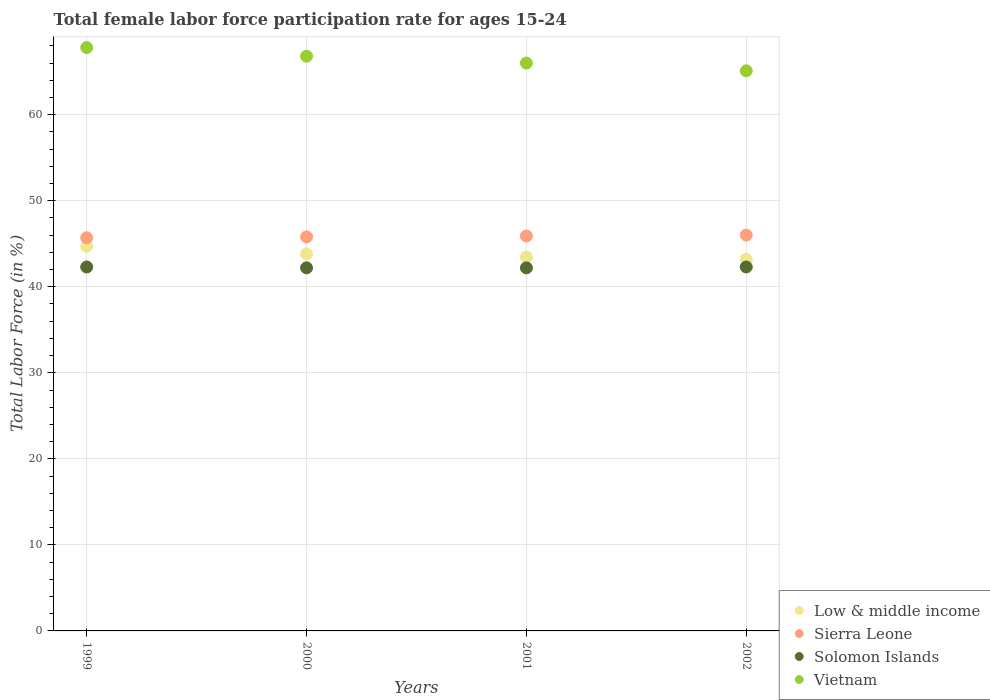How many different coloured dotlines are there?
Make the answer very short. 4. Is the number of dotlines equal to the number of legend labels?
Give a very brief answer. Yes. What is the female labor force participation rate in Low & middle income in 2002?
Keep it short and to the point. 43.2. Across all years, what is the maximum female labor force participation rate in Solomon Islands?
Offer a terse response. 42.3. Across all years, what is the minimum female labor force participation rate in Sierra Leone?
Your answer should be very brief. 45.7. In which year was the female labor force participation rate in Sierra Leone maximum?
Offer a very short reply. 2002. What is the total female labor force participation rate in Sierra Leone in the graph?
Offer a very short reply. 183.4. What is the difference between the female labor force participation rate in Solomon Islands in 2001 and that in 2002?
Provide a short and direct response. -0.1. What is the difference between the female labor force participation rate in Low & middle income in 2002 and the female labor force participation rate in Solomon Islands in 2001?
Keep it short and to the point. 1. What is the average female labor force participation rate in Solomon Islands per year?
Offer a very short reply. 42.25. In the year 1999, what is the difference between the female labor force participation rate in Low & middle income and female labor force participation rate in Solomon Islands?
Provide a short and direct response. 2.4. What is the ratio of the female labor force participation rate in Sierra Leone in 1999 to that in 2000?
Provide a succinct answer. 1. Is the female labor force participation rate in Sierra Leone in 2000 less than that in 2001?
Provide a succinct answer. Yes. What is the difference between the highest and the second highest female labor force participation rate in Sierra Leone?
Your answer should be very brief. 0.1. What is the difference between the highest and the lowest female labor force participation rate in Low & middle income?
Offer a terse response. 1.5. In how many years, is the female labor force participation rate in Solomon Islands greater than the average female labor force participation rate in Solomon Islands taken over all years?
Make the answer very short. 2. How many dotlines are there?
Provide a succinct answer. 4. How many years are there in the graph?
Your answer should be very brief. 4. Are the values on the major ticks of Y-axis written in scientific E-notation?
Make the answer very short. No. Does the graph contain grids?
Provide a short and direct response. Yes. What is the title of the graph?
Provide a short and direct response. Total female labor force participation rate for ages 15-24. What is the label or title of the Y-axis?
Your answer should be compact. Total Labor Force (in %). What is the Total Labor Force (in %) of Low & middle income in 1999?
Make the answer very short. 44.7. What is the Total Labor Force (in %) of Sierra Leone in 1999?
Give a very brief answer. 45.7. What is the Total Labor Force (in %) in Solomon Islands in 1999?
Your response must be concise. 42.3. What is the Total Labor Force (in %) of Vietnam in 1999?
Give a very brief answer. 67.8. What is the Total Labor Force (in %) in Low & middle income in 2000?
Offer a terse response. 43.82. What is the Total Labor Force (in %) of Sierra Leone in 2000?
Your answer should be compact. 45.8. What is the Total Labor Force (in %) in Solomon Islands in 2000?
Provide a succinct answer. 42.2. What is the Total Labor Force (in %) of Vietnam in 2000?
Keep it short and to the point. 66.8. What is the Total Labor Force (in %) in Low & middle income in 2001?
Give a very brief answer. 43.44. What is the Total Labor Force (in %) in Sierra Leone in 2001?
Provide a short and direct response. 45.9. What is the Total Labor Force (in %) of Solomon Islands in 2001?
Give a very brief answer. 42.2. What is the Total Labor Force (in %) of Vietnam in 2001?
Provide a succinct answer. 66. What is the Total Labor Force (in %) of Low & middle income in 2002?
Offer a terse response. 43.2. What is the Total Labor Force (in %) of Sierra Leone in 2002?
Your answer should be very brief. 46. What is the Total Labor Force (in %) in Solomon Islands in 2002?
Your response must be concise. 42.3. What is the Total Labor Force (in %) in Vietnam in 2002?
Your response must be concise. 65.1. Across all years, what is the maximum Total Labor Force (in %) of Low & middle income?
Make the answer very short. 44.7. Across all years, what is the maximum Total Labor Force (in %) of Solomon Islands?
Keep it short and to the point. 42.3. Across all years, what is the maximum Total Labor Force (in %) in Vietnam?
Offer a terse response. 67.8. Across all years, what is the minimum Total Labor Force (in %) of Low & middle income?
Offer a very short reply. 43.2. Across all years, what is the minimum Total Labor Force (in %) of Sierra Leone?
Your response must be concise. 45.7. Across all years, what is the minimum Total Labor Force (in %) in Solomon Islands?
Offer a very short reply. 42.2. Across all years, what is the minimum Total Labor Force (in %) of Vietnam?
Offer a terse response. 65.1. What is the total Total Labor Force (in %) of Low & middle income in the graph?
Offer a terse response. 175.16. What is the total Total Labor Force (in %) of Sierra Leone in the graph?
Give a very brief answer. 183.4. What is the total Total Labor Force (in %) in Solomon Islands in the graph?
Your answer should be very brief. 169. What is the total Total Labor Force (in %) of Vietnam in the graph?
Give a very brief answer. 265.7. What is the difference between the Total Labor Force (in %) of Low & middle income in 1999 and that in 2000?
Give a very brief answer. 0.88. What is the difference between the Total Labor Force (in %) in Sierra Leone in 1999 and that in 2000?
Your answer should be very brief. -0.1. What is the difference between the Total Labor Force (in %) of Vietnam in 1999 and that in 2000?
Keep it short and to the point. 1. What is the difference between the Total Labor Force (in %) in Low & middle income in 1999 and that in 2001?
Keep it short and to the point. 1.26. What is the difference between the Total Labor Force (in %) of Sierra Leone in 1999 and that in 2001?
Make the answer very short. -0.2. What is the difference between the Total Labor Force (in %) in Solomon Islands in 1999 and that in 2001?
Make the answer very short. 0.1. What is the difference between the Total Labor Force (in %) of Low & middle income in 1999 and that in 2002?
Your answer should be compact. 1.5. What is the difference between the Total Labor Force (in %) of Low & middle income in 2000 and that in 2001?
Offer a terse response. 0.38. What is the difference between the Total Labor Force (in %) of Solomon Islands in 2000 and that in 2001?
Ensure brevity in your answer.  0. What is the difference between the Total Labor Force (in %) in Low & middle income in 2000 and that in 2002?
Give a very brief answer. 0.61. What is the difference between the Total Labor Force (in %) in Sierra Leone in 2000 and that in 2002?
Offer a very short reply. -0.2. What is the difference between the Total Labor Force (in %) in Solomon Islands in 2000 and that in 2002?
Give a very brief answer. -0.1. What is the difference between the Total Labor Force (in %) of Vietnam in 2000 and that in 2002?
Your answer should be compact. 1.7. What is the difference between the Total Labor Force (in %) of Low & middle income in 2001 and that in 2002?
Ensure brevity in your answer.  0.24. What is the difference between the Total Labor Force (in %) of Sierra Leone in 2001 and that in 2002?
Provide a succinct answer. -0.1. What is the difference between the Total Labor Force (in %) of Low & middle income in 1999 and the Total Labor Force (in %) of Sierra Leone in 2000?
Offer a terse response. -1.1. What is the difference between the Total Labor Force (in %) of Low & middle income in 1999 and the Total Labor Force (in %) of Solomon Islands in 2000?
Provide a short and direct response. 2.5. What is the difference between the Total Labor Force (in %) of Low & middle income in 1999 and the Total Labor Force (in %) of Vietnam in 2000?
Your response must be concise. -22.1. What is the difference between the Total Labor Force (in %) of Sierra Leone in 1999 and the Total Labor Force (in %) of Solomon Islands in 2000?
Make the answer very short. 3.5. What is the difference between the Total Labor Force (in %) of Sierra Leone in 1999 and the Total Labor Force (in %) of Vietnam in 2000?
Ensure brevity in your answer.  -21.1. What is the difference between the Total Labor Force (in %) of Solomon Islands in 1999 and the Total Labor Force (in %) of Vietnam in 2000?
Your answer should be very brief. -24.5. What is the difference between the Total Labor Force (in %) of Low & middle income in 1999 and the Total Labor Force (in %) of Sierra Leone in 2001?
Provide a short and direct response. -1.2. What is the difference between the Total Labor Force (in %) of Low & middle income in 1999 and the Total Labor Force (in %) of Solomon Islands in 2001?
Provide a short and direct response. 2.5. What is the difference between the Total Labor Force (in %) in Low & middle income in 1999 and the Total Labor Force (in %) in Vietnam in 2001?
Give a very brief answer. -21.3. What is the difference between the Total Labor Force (in %) in Sierra Leone in 1999 and the Total Labor Force (in %) in Solomon Islands in 2001?
Your response must be concise. 3.5. What is the difference between the Total Labor Force (in %) of Sierra Leone in 1999 and the Total Labor Force (in %) of Vietnam in 2001?
Ensure brevity in your answer.  -20.3. What is the difference between the Total Labor Force (in %) in Solomon Islands in 1999 and the Total Labor Force (in %) in Vietnam in 2001?
Offer a very short reply. -23.7. What is the difference between the Total Labor Force (in %) of Low & middle income in 1999 and the Total Labor Force (in %) of Sierra Leone in 2002?
Provide a short and direct response. -1.3. What is the difference between the Total Labor Force (in %) in Low & middle income in 1999 and the Total Labor Force (in %) in Solomon Islands in 2002?
Offer a terse response. 2.4. What is the difference between the Total Labor Force (in %) in Low & middle income in 1999 and the Total Labor Force (in %) in Vietnam in 2002?
Offer a very short reply. -20.4. What is the difference between the Total Labor Force (in %) in Sierra Leone in 1999 and the Total Labor Force (in %) in Vietnam in 2002?
Your response must be concise. -19.4. What is the difference between the Total Labor Force (in %) of Solomon Islands in 1999 and the Total Labor Force (in %) of Vietnam in 2002?
Ensure brevity in your answer.  -22.8. What is the difference between the Total Labor Force (in %) of Low & middle income in 2000 and the Total Labor Force (in %) of Sierra Leone in 2001?
Your answer should be compact. -2.08. What is the difference between the Total Labor Force (in %) in Low & middle income in 2000 and the Total Labor Force (in %) in Solomon Islands in 2001?
Offer a very short reply. 1.62. What is the difference between the Total Labor Force (in %) of Low & middle income in 2000 and the Total Labor Force (in %) of Vietnam in 2001?
Make the answer very short. -22.18. What is the difference between the Total Labor Force (in %) in Sierra Leone in 2000 and the Total Labor Force (in %) in Vietnam in 2001?
Your response must be concise. -20.2. What is the difference between the Total Labor Force (in %) in Solomon Islands in 2000 and the Total Labor Force (in %) in Vietnam in 2001?
Offer a terse response. -23.8. What is the difference between the Total Labor Force (in %) of Low & middle income in 2000 and the Total Labor Force (in %) of Sierra Leone in 2002?
Your response must be concise. -2.18. What is the difference between the Total Labor Force (in %) in Low & middle income in 2000 and the Total Labor Force (in %) in Solomon Islands in 2002?
Your response must be concise. 1.52. What is the difference between the Total Labor Force (in %) of Low & middle income in 2000 and the Total Labor Force (in %) of Vietnam in 2002?
Your answer should be very brief. -21.28. What is the difference between the Total Labor Force (in %) of Sierra Leone in 2000 and the Total Labor Force (in %) of Vietnam in 2002?
Provide a succinct answer. -19.3. What is the difference between the Total Labor Force (in %) of Solomon Islands in 2000 and the Total Labor Force (in %) of Vietnam in 2002?
Ensure brevity in your answer.  -22.9. What is the difference between the Total Labor Force (in %) of Low & middle income in 2001 and the Total Labor Force (in %) of Sierra Leone in 2002?
Give a very brief answer. -2.56. What is the difference between the Total Labor Force (in %) in Low & middle income in 2001 and the Total Labor Force (in %) in Solomon Islands in 2002?
Offer a very short reply. 1.14. What is the difference between the Total Labor Force (in %) in Low & middle income in 2001 and the Total Labor Force (in %) in Vietnam in 2002?
Provide a short and direct response. -21.66. What is the difference between the Total Labor Force (in %) in Sierra Leone in 2001 and the Total Labor Force (in %) in Vietnam in 2002?
Provide a short and direct response. -19.2. What is the difference between the Total Labor Force (in %) of Solomon Islands in 2001 and the Total Labor Force (in %) of Vietnam in 2002?
Your answer should be very brief. -22.9. What is the average Total Labor Force (in %) in Low & middle income per year?
Keep it short and to the point. 43.79. What is the average Total Labor Force (in %) of Sierra Leone per year?
Your answer should be very brief. 45.85. What is the average Total Labor Force (in %) of Solomon Islands per year?
Your answer should be very brief. 42.25. What is the average Total Labor Force (in %) of Vietnam per year?
Keep it short and to the point. 66.42. In the year 1999, what is the difference between the Total Labor Force (in %) in Low & middle income and Total Labor Force (in %) in Sierra Leone?
Provide a short and direct response. -1. In the year 1999, what is the difference between the Total Labor Force (in %) of Low & middle income and Total Labor Force (in %) of Solomon Islands?
Your answer should be compact. 2.4. In the year 1999, what is the difference between the Total Labor Force (in %) in Low & middle income and Total Labor Force (in %) in Vietnam?
Your answer should be very brief. -23.1. In the year 1999, what is the difference between the Total Labor Force (in %) of Sierra Leone and Total Labor Force (in %) of Solomon Islands?
Provide a succinct answer. 3.4. In the year 1999, what is the difference between the Total Labor Force (in %) of Sierra Leone and Total Labor Force (in %) of Vietnam?
Offer a very short reply. -22.1. In the year 1999, what is the difference between the Total Labor Force (in %) in Solomon Islands and Total Labor Force (in %) in Vietnam?
Give a very brief answer. -25.5. In the year 2000, what is the difference between the Total Labor Force (in %) in Low & middle income and Total Labor Force (in %) in Sierra Leone?
Provide a short and direct response. -1.98. In the year 2000, what is the difference between the Total Labor Force (in %) in Low & middle income and Total Labor Force (in %) in Solomon Islands?
Your response must be concise. 1.62. In the year 2000, what is the difference between the Total Labor Force (in %) of Low & middle income and Total Labor Force (in %) of Vietnam?
Provide a succinct answer. -22.98. In the year 2000, what is the difference between the Total Labor Force (in %) of Sierra Leone and Total Labor Force (in %) of Vietnam?
Give a very brief answer. -21. In the year 2000, what is the difference between the Total Labor Force (in %) in Solomon Islands and Total Labor Force (in %) in Vietnam?
Your answer should be very brief. -24.6. In the year 2001, what is the difference between the Total Labor Force (in %) of Low & middle income and Total Labor Force (in %) of Sierra Leone?
Offer a terse response. -2.46. In the year 2001, what is the difference between the Total Labor Force (in %) of Low & middle income and Total Labor Force (in %) of Solomon Islands?
Your answer should be compact. 1.24. In the year 2001, what is the difference between the Total Labor Force (in %) in Low & middle income and Total Labor Force (in %) in Vietnam?
Your response must be concise. -22.56. In the year 2001, what is the difference between the Total Labor Force (in %) in Sierra Leone and Total Labor Force (in %) in Vietnam?
Your answer should be compact. -20.1. In the year 2001, what is the difference between the Total Labor Force (in %) in Solomon Islands and Total Labor Force (in %) in Vietnam?
Your answer should be compact. -23.8. In the year 2002, what is the difference between the Total Labor Force (in %) of Low & middle income and Total Labor Force (in %) of Sierra Leone?
Make the answer very short. -2.8. In the year 2002, what is the difference between the Total Labor Force (in %) of Low & middle income and Total Labor Force (in %) of Solomon Islands?
Offer a terse response. 0.9. In the year 2002, what is the difference between the Total Labor Force (in %) in Low & middle income and Total Labor Force (in %) in Vietnam?
Ensure brevity in your answer.  -21.9. In the year 2002, what is the difference between the Total Labor Force (in %) in Sierra Leone and Total Labor Force (in %) in Solomon Islands?
Your answer should be very brief. 3.7. In the year 2002, what is the difference between the Total Labor Force (in %) in Sierra Leone and Total Labor Force (in %) in Vietnam?
Make the answer very short. -19.1. In the year 2002, what is the difference between the Total Labor Force (in %) in Solomon Islands and Total Labor Force (in %) in Vietnam?
Offer a very short reply. -22.8. What is the ratio of the Total Labor Force (in %) in Low & middle income in 1999 to that in 2000?
Ensure brevity in your answer.  1.02. What is the ratio of the Total Labor Force (in %) in Sierra Leone in 1999 to that in 2000?
Offer a terse response. 1. What is the ratio of the Total Labor Force (in %) of Solomon Islands in 1999 to that in 2000?
Make the answer very short. 1. What is the ratio of the Total Labor Force (in %) of Vietnam in 1999 to that in 2000?
Offer a very short reply. 1.01. What is the ratio of the Total Labor Force (in %) of Low & middle income in 1999 to that in 2001?
Your response must be concise. 1.03. What is the ratio of the Total Labor Force (in %) in Sierra Leone in 1999 to that in 2001?
Keep it short and to the point. 1. What is the ratio of the Total Labor Force (in %) in Solomon Islands in 1999 to that in 2001?
Offer a very short reply. 1. What is the ratio of the Total Labor Force (in %) of Vietnam in 1999 to that in 2001?
Your answer should be compact. 1.03. What is the ratio of the Total Labor Force (in %) in Low & middle income in 1999 to that in 2002?
Offer a very short reply. 1.03. What is the ratio of the Total Labor Force (in %) in Solomon Islands in 1999 to that in 2002?
Ensure brevity in your answer.  1. What is the ratio of the Total Labor Force (in %) in Vietnam in 1999 to that in 2002?
Your answer should be compact. 1.04. What is the ratio of the Total Labor Force (in %) of Low & middle income in 2000 to that in 2001?
Give a very brief answer. 1.01. What is the ratio of the Total Labor Force (in %) of Vietnam in 2000 to that in 2001?
Make the answer very short. 1.01. What is the ratio of the Total Labor Force (in %) of Low & middle income in 2000 to that in 2002?
Offer a very short reply. 1.01. What is the ratio of the Total Labor Force (in %) in Solomon Islands in 2000 to that in 2002?
Offer a terse response. 1. What is the ratio of the Total Labor Force (in %) of Vietnam in 2000 to that in 2002?
Your answer should be very brief. 1.03. What is the ratio of the Total Labor Force (in %) in Low & middle income in 2001 to that in 2002?
Ensure brevity in your answer.  1.01. What is the ratio of the Total Labor Force (in %) of Vietnam in 2001 to that in 2002?
Provide a succinct answer. 1.01. What is the difference between the highest and the second highest Total Labor Force (in %) of Low & middle income?
Make the answer very short. 0.88. What is the difference between the highest and the second highest Total Labor Force (in %) in Sierra Leone?
Your answer should be compact. 0.1. What is the difference between the highest and the lowest Total Labor Force (in %) of Low & middle income?
Provide a succinct answer. 1.5. What is the difference between the highest and the lowest Total Labor Force (in %) in Sierra Leone?
Ensure brevity in your answer.  0.3. 